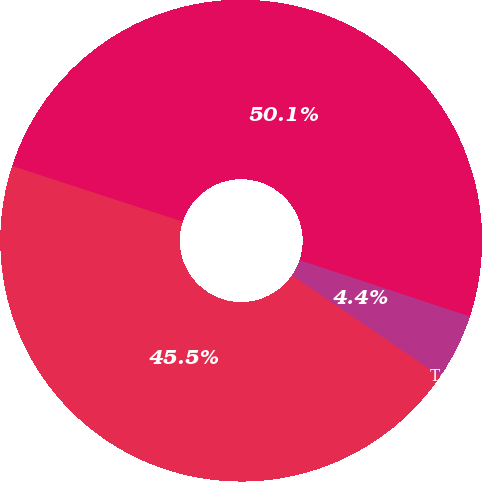Convert chart. <chart><loc_0><loc_0><loc_500><loc_500><pie_chart><fcel>Rental<fcel>Tenant reimbursements<fcel>Total operating revenues<nl><fcel>45.52%<fcel>4.41%<fcel>50.07%<nl></chart> 